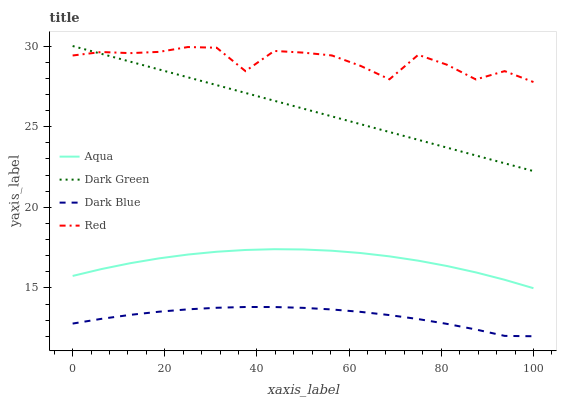Does Dark Blue have the minimum area under the curve?
Answer yes or no. Yes. Does Red have the maximum area under the curve?
Answer yes or no. Yes. Does Aqua have the minimum area under the curve?
Answer yes or no. No. Does Aqua have the maximum area under the curve?
Answer yes or no. No. Is Dark Green the smoothest?
Answer yes or no. Yes. Is Red the roughest?
Answer yes or no. Yes. Is Aqua the smoothest?
Answer yes or no. No. Is Aqua the roughest?
Answer yes or no. No. Does Aqua have the lowest value?
Answer yes or no. No. Does Aqua have the highest value?
Answer yes or no. No. Is Dark Blue less than Red?
Answer yes or no. Yes. Is Red greater than Dark Blue?
Answer yes or no. Yes. Does Dark Blue intersect Red?
Answer yes or no. No. 